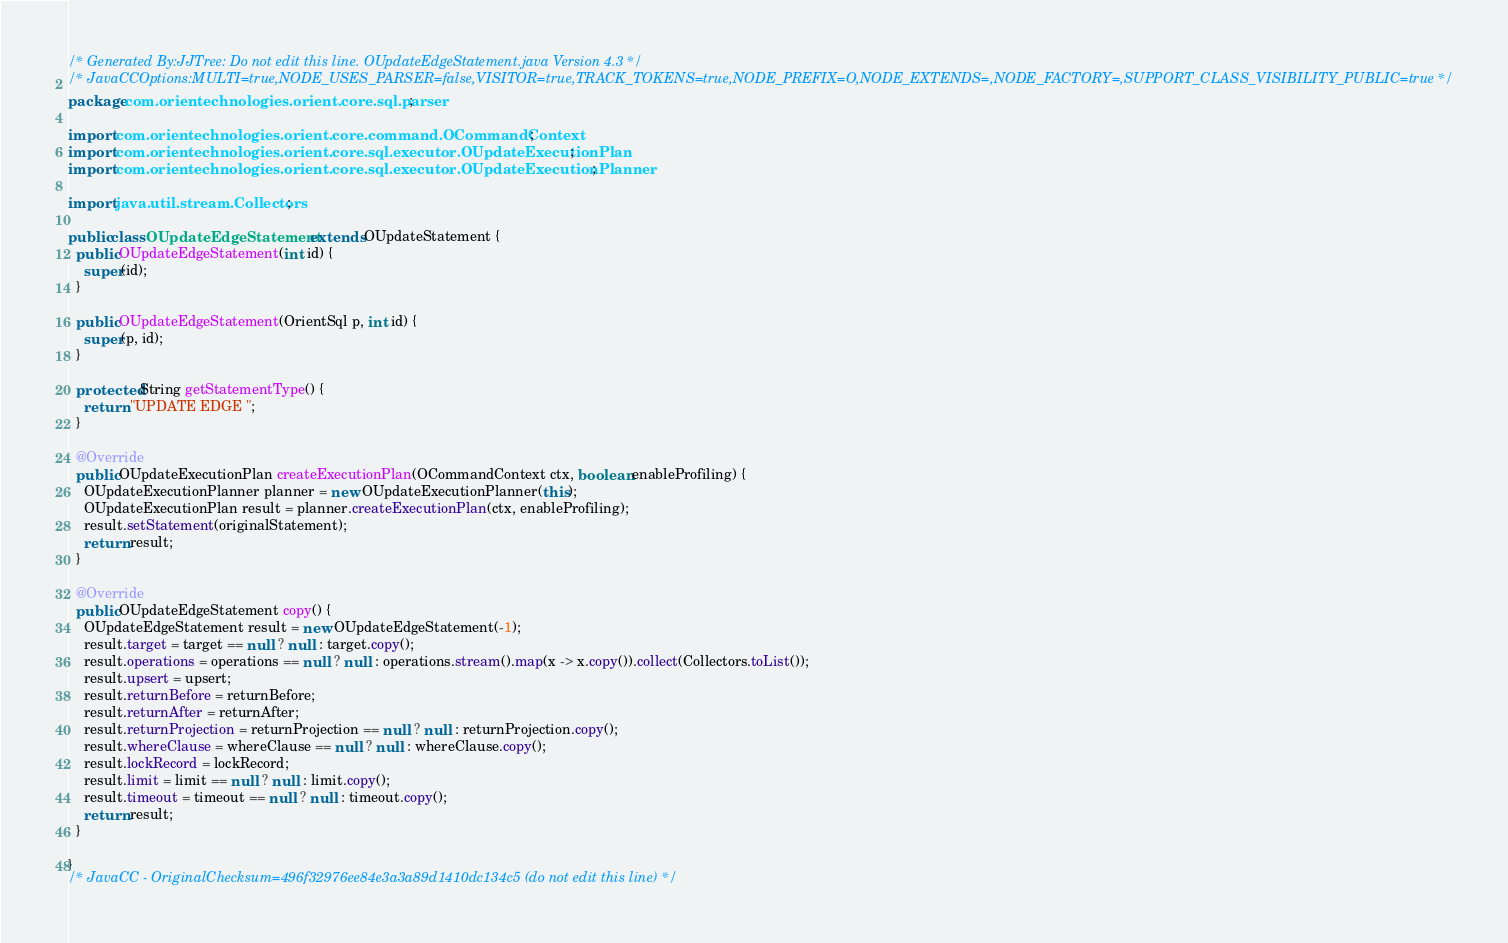Convert code to text. <code><loc_0><loc_0><loc_500><loc_500><_Java_>/* Generated By:JJTree: Do not edit this line. OUpdateEdgeStatement.java Version 4.3 */
/* JavaCCOptions:MULTI=true,NODE_USES_PARSER=false,VISITOR=true,TRACK_TOKENS=true,NODE_PREFIX=O,NODE_EXTENDS=,NODE_FACTORY=,SUPPORT_CLASS_VISIBILITY_PUBLIC=true */
package com.orientechnologies.orient.core.sql.parser;

import com.orientechnologies.orient.core.command.OCommandContext;
import com.orientechnologies.orient.core.sql.executor.OUpdateExecutionPlan;
import com.orientechnologies.orient.core.sql.executor.OUpdateExecutionPlanner;

import java.util.stream.Collectors;

public class OUpdateEdgeStatement extends OUpdateStatement {
  public OUpdateEdgeStatement(int id) {
    super(id);
  }

  public OUpdateEdgeStatement(OrientSql p, int id) {
    super(p, id);
  }

  protected String getStatementType() {
    return "UPDATE EDGE ";
  }

  @Override
  public OUpdateExecutionPlan createExecutionPlan(OCommandContext ctx, boolean enableProfiling) {
    OUpdateExecutionPlanner planner = new OUpdateExecutionPlanner(this);
    OUpdateExecutionPlan result = planner.createExecutionPlan(ctx, enableProfiling);
    result.setStatement(originalStatement);
    return result;
  }

  @Override
  public OUpdateEdgeStatement copy() {
    OUpdateEdgeStatement result = new OUpdateEdgeStatement(-1);
    result.target = target == null ? null : target.copy();
    result.operations = operations == null ? null : operations.stream().map(x -> x.copy()).collect(Collectors.toList());
    result.upsert = upsert;
    result.returnBefore = returnBefore;
    result.returnAfter = returnAfter;
    result.returnProjection = returnProjection == null ? null : returnProjection.copy();
    result.whereClause = whereClause == null ? null : whereClause.copy();
    result.lockRecord = lockRecord;
    result.limit = limit == null ? null : limit.copy();
    result.timeout = timeout == null ? null : timeout.copy();
    return result;
  }

}
/* JavaCC - OriginalChecksum=496f32976ee84e3a3a89d1410dc134c5 (do not edit this line) */
</code> 